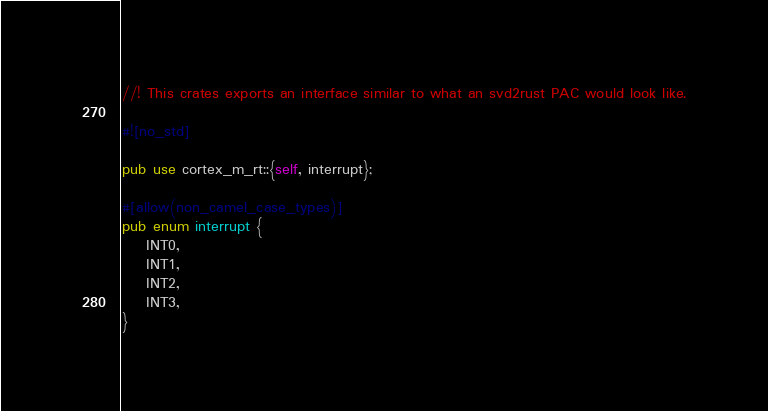<code> <loc_0><loc_0><loc_500><loc_500><_Rust_>//! This crates exports an interface similar to what an svd2rust PAC would look like.

#![no_std]

pub use cortex_m_rt::{self, interrupt};

#[allow(non_camel_case_types)]
pub enum interrupt {
    INT0,
    INT1,
    INT2,
    INT3,
}
</code> 